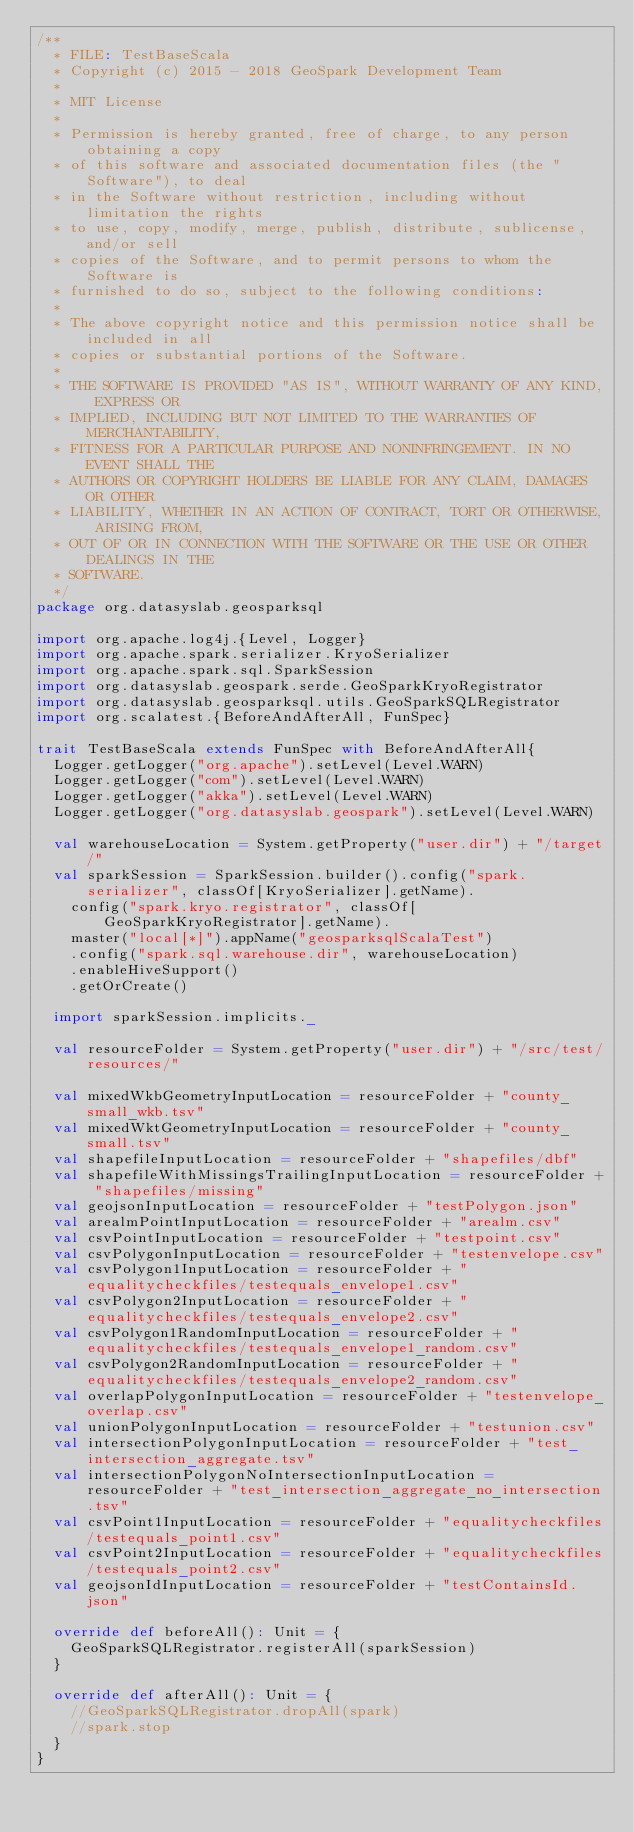Convert code to text. <code><loc_0><loc_0><loc_500><loc_500><_Scala_>/**
  * FILE: TestBaseScala
  * Copyright (c) 2015 - 2018 GeoSpark Development Team
  *
  * MIT License
  *
  * Permission is hereby granted, free of charge, to any person obtaining a copy
  * of this software and associated documentation files (the "Software"), to deal
  * in the Software without restriction, including without limitation the rights
  * to use, copy, modify, merge, publish, distribute, sublicense, and/or sell
  * copies of the Software, and to permit persons to whom the Software is
  * furnished to do so, subject to the following conditions:
  *
  * The above copyright notice and this permission notice shall be included in all
  * copies or substantial portions of the Software.
  *
  * THE SOFTWARE IS PROVIDED "AS IS", WITHOUT WARRANTY OF ANY KIND, EXPRESS OR
  * IMPLIED, INCLUDING BUT NOT LIMITED TO THE WARRANTIES OF MERCHANTABILITY,
  * FITNESS FOR A PARTICULAR PURPOSE AND NONINFRINGEMENT. IN NO EVENT SHALL THE
  * AUTHORS OR COPYRIGHT HOLDERS BE LIABLE FOR ANY CLAIM, DAMAGES OR OTHER
  * LIABILITY, WHETHER IN AN ACTION OF CONTRACT, TORT OR OTHERWISE, ARISING FROM,
  * OUT OF OR IN CONNECTION WITH THE SOFTWARE OR THE USE OR OTHER DEALINGS IN THE
  * SOFTWARE.
  */
package org.datasyslab.geosparksql

import org.apache.log4j.{Level, Logger}
import org.apache.spark.serializer.KryoSerializer
import org.apache.spark.sql.SparkSession
import org.datasyslab.geospark.serde.GeoSparkKryoRegistrator
import org.datasyslab.geosparksql.utils.GeoSparkSQLRegistrator
import org.scalatest.{BeforeAndAfterAll, FunSpec}

trait TestBaseScala extends FunSpec with BeforeAndAfterAll{
  Logger.getLogger("org.apache").setLevel(Level.WARN)
  Logger.getLogger("com").setLevel(Level.WARN)
  Logger.getLogger("akka").setLevel(Level.WARN)
  Logger.getLogger("org.datasyslab.geospark").setLevel(Level.WARN)

  val warehouseLocation = System.getProperty("user.dir") + "/target/"
  val sparkSession = SparkSession.builder().config("spark.serializer", classOf[KryoSerializer].getName).
    config("spark.kryo.registrator", classOf[GeoSparkKryoRegistrator].getName).
    master("local[*]").appName("geosparksqlScalaTest")
    .config("spark.sql.warehouse.dir", warehouseLocation)
    .enableHiveSupport()
    .getOrCreate()

  import sparkSession.implicits._

  val resourceFolder = System.getProperty("user.dir") + "/src/test/resources/"

  val mixedWkbGeometryInputLocation = resourceFolder + "county_small_wkb.tsv"
  val mixedWktGeometryInputLocation = resourceFolder + "county_small.tsv"
  val shapefileInputLocation = resourceFolder + "shapefiles/dbf"
  val shapefileWithMissingsTrailingInputLocation = resourceFolder + "shapefiles/missing"
  val geojsonInputLocation = resourceFolder + "testPolygon.json"
  val arealmPointInputLocation = resourceFolder + "arealm.csv"
  val csvPointInputLocation = resourceFolder + "testpoint.csv"
  val csvPolygonInputLocation = resourceFolder + "testenvelope.csv"
  val csvPolygon1InputLocation = resourceFolder + "equalitycheckfiles/testequals_envelope1.csv"
  val csvPolygon2InputLocation = resourceFolder + "equalitycheckfiles/testequals_envelope2.csv"
  val csvPolygon1RandomInputLocation = resourceFolder + "equalitycheckfiles/testequals_envelope1_random.csv"
  val csvPolygon2RandomInputLocation = resourceFolder + "equalitycheckfiles/testequals_envelope2_random.csv"
  val overlapPolygonInputLocation = resourceFolder + "testenvelope_overlap.csv"
  val unionPolygonInputLocation = resourceFolder + "testunion.csv"
  val intersectionPolygonInputLocation = resourceFolder + "test_intersection_aggregate.tsv"
  val intersectionPolygonNoIntersectionInputLocation = resourceFolder + "test_intersection_aggregate_no_intersection.tsv"
  val csvPoint1InputLocation = resourceFolder + "equalitycheckfiles/testequals_point1.csv"
  val csvPoint2InputLocation = resourceFolder + "equalitycheckfiles/testequals_point2.csv"
  val geojsonIdInputLocation = resourceFolder + "testContainsId.json"

  override def beforeAll(): Unit = {
    GeoSparkSQLRegistrator.registerAll(sparkSession)
  }

  override def afterAll(): Unit = {
    //GeoSparkSQLRegistrator.dropAll(spark)
    //spark.stop
  }
}
</code> 